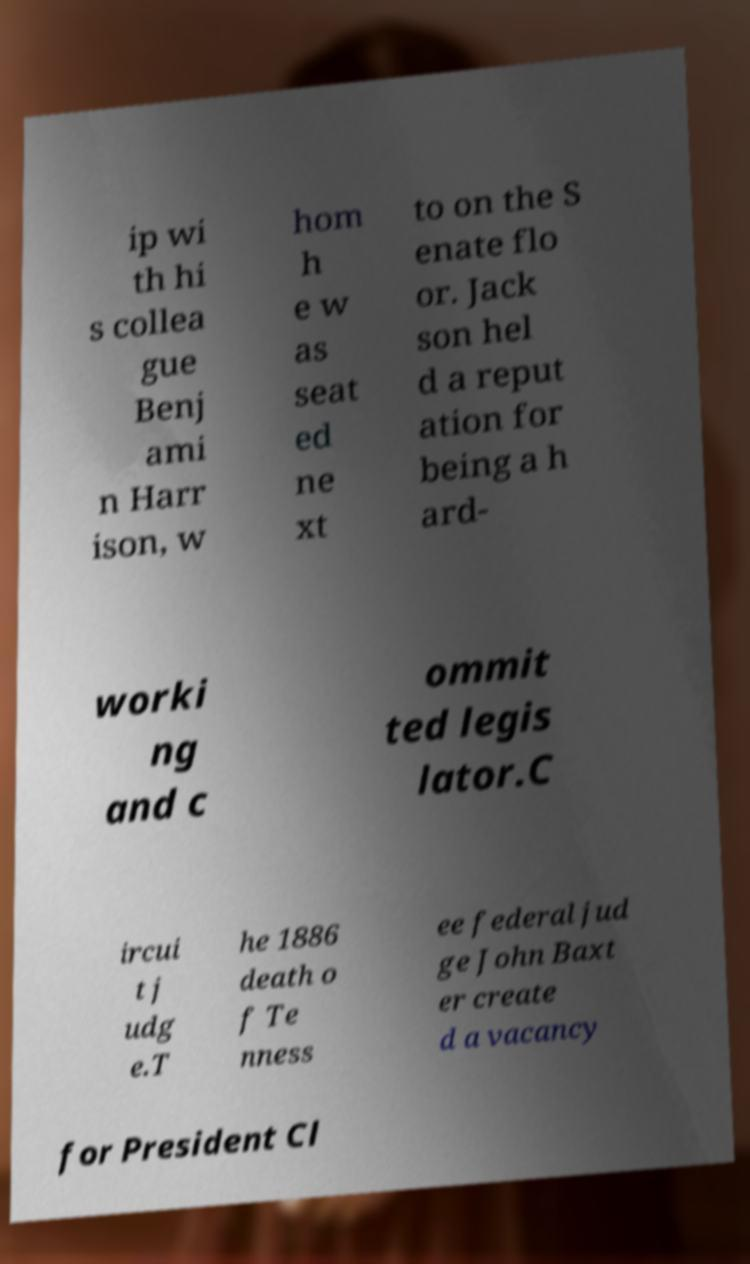For documentation purposes, I need the text within this image transcribed. Could you provide that? ip wi th hi s collea gue Benj ami n Harr ison, w hom h e w as seat ed ne xt to on the S enate flo or. Jack son hel d a reput ation for being a h ard- worki ng and c ommit ted legis lator.C ircui t j udg e.T he 1886 death o f Te nness ee federal jud ge John Baxt er create d a vacancy for President Cl 